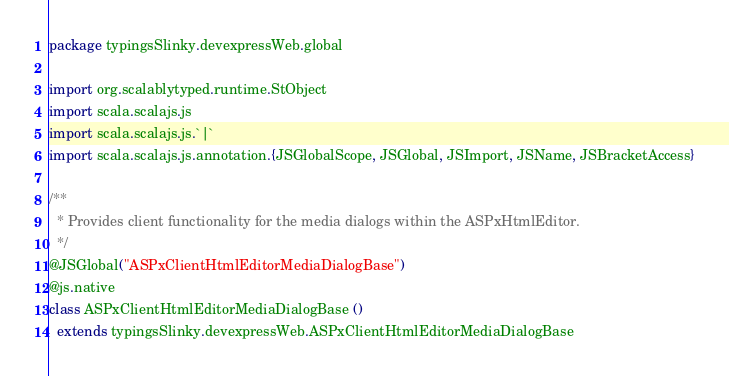<code> <loc_0><loc_0><loc_500><loc_500><_Scala_>package typingsSlinky.devexpressWeb.global

import org.scalablytyped.runtime.StObject
import scala.scalajs.js
import scala.scalajs.js.`|`
import scala.scalajs.js.annotation.{JSGlobalScope, JSGlobal, JSImport, JSName, JSBracketAccess}

/**
  * Provides client functionality for the media dialogs within the ASPxHtmlEditor.
  */
@JSGlobal("ASPxClientHtmlEditorMediaDialogBase")
@js.native
class ASPxClientHtmlEditorMediaDialogBase ()
  extends typingsSlinky.devexpressWeb.ASPxClientHtmlEditorMediaDialogBase
</code> 